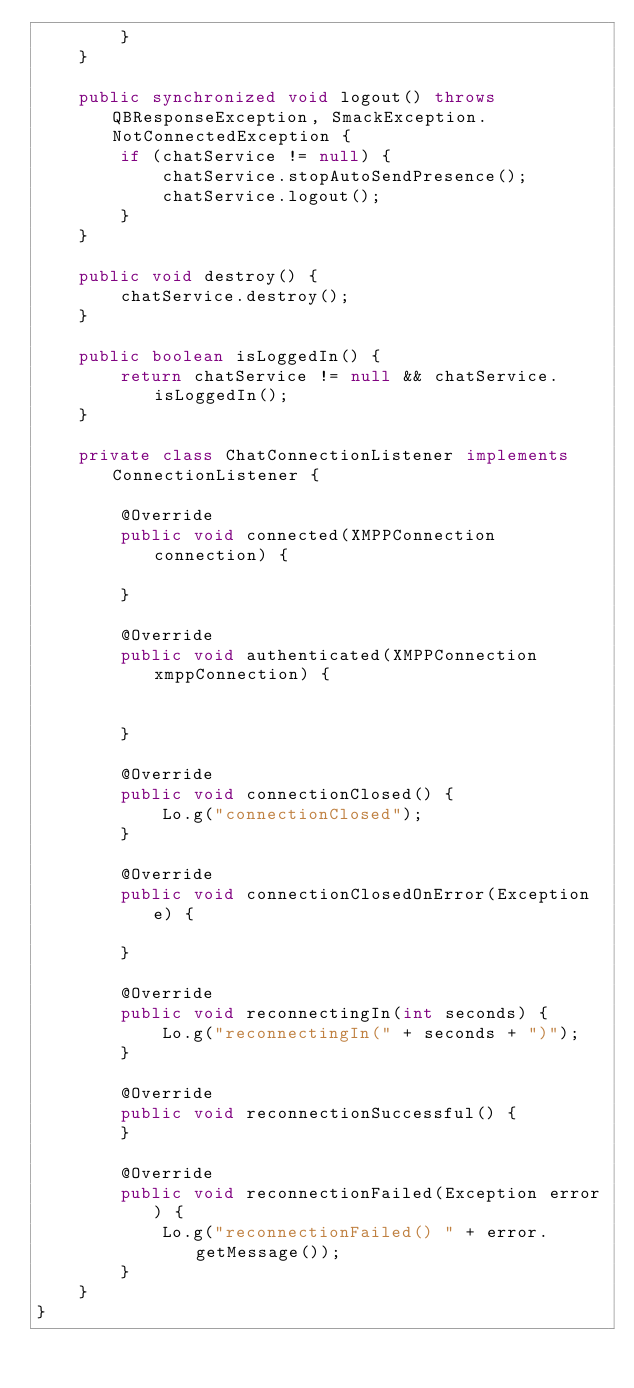Convert code to text. <code><loc_0><loc_0><loc_500><loc_500><_Java_>        }
    }

    public synchronized void logout() throws QBResponseException, SmackException.NotConnectedException {
        if (chatService != null) {
            chatService.stopAutoSendPresence();
            chatService.logout();
        }
    }

    public void destroy() {
        chatService.destroy();
    }

    public boolean isLoggedIn() {
        return chatService != null && chatService.isLoggedIn();
    }

    private class ChatConnectionListener implements ConnectionListener {

        @Override
        public void connected(XMPPConnection connection) {

        }

        @Override
        public void authenticated(XMPPConnection xmppConnection) {


        }

        @Override
        public void connectionClosed() {
            Lo.g("connectionClosed");
        }

        @Override
        public void connectionClosedOnError(Exception e) {

        }

        @Override
        public void reconnectingIn(int seconds) {
            Lo.g("reconnectingIn(" + seconds + ")");
        }

        @Override
        public void reconnectionSuccessful() {
        }

        @Override
        public void reconnectionFailed(Exception error) {
            Lo.g("reconnectionFailed() " + error.getMessage());
        }
    }
}
</code> 